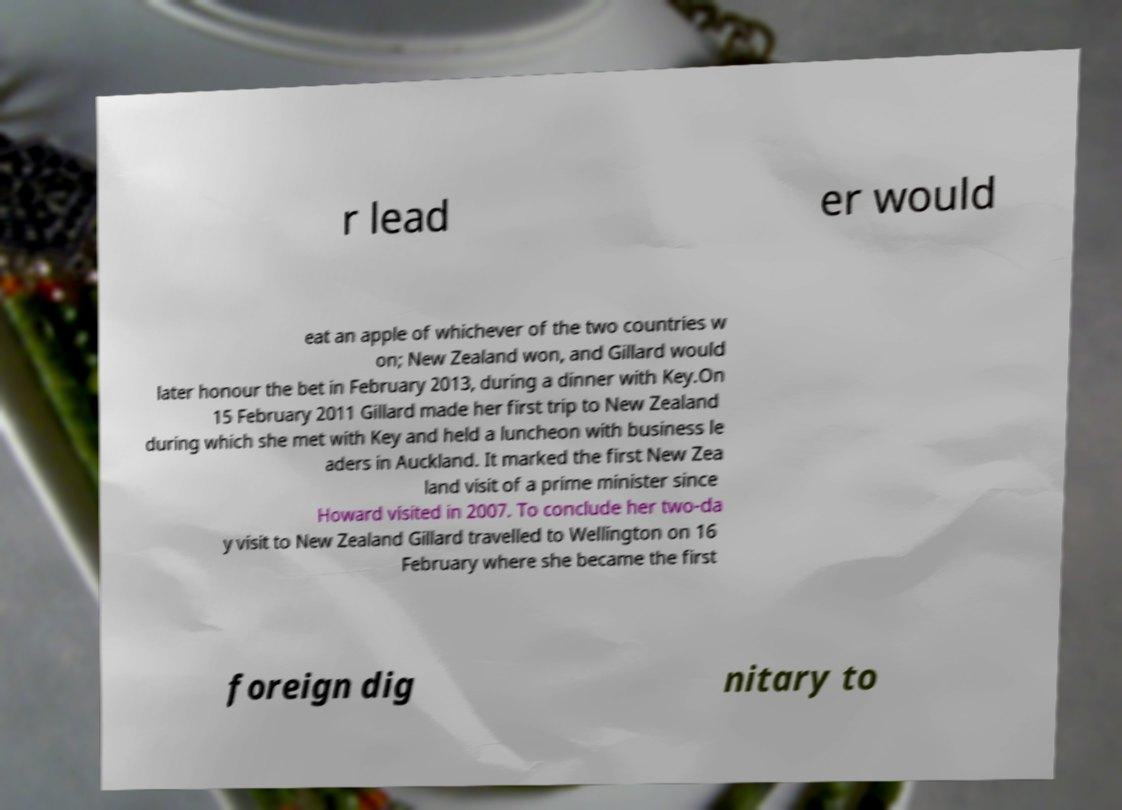I need the written content from this picture converted into text. Can you do that? r lead er would eat an apple of whichever of the two countries w on; New Zealand won, and Gillard would later honour the bet in February 2013, during a dinner with Key.On 15 February 2011 Gillard made her first trip to New Zealand during which she met with Key and held a luncheon with business le aders in Auckland. It marked the first New Zea land visit of a prime minister since Howard visited in 2007. To conclude her two-da y visit to New Zealand Gillard travelled to Wellington on 16 February where she became the first foreign dig nitary to 